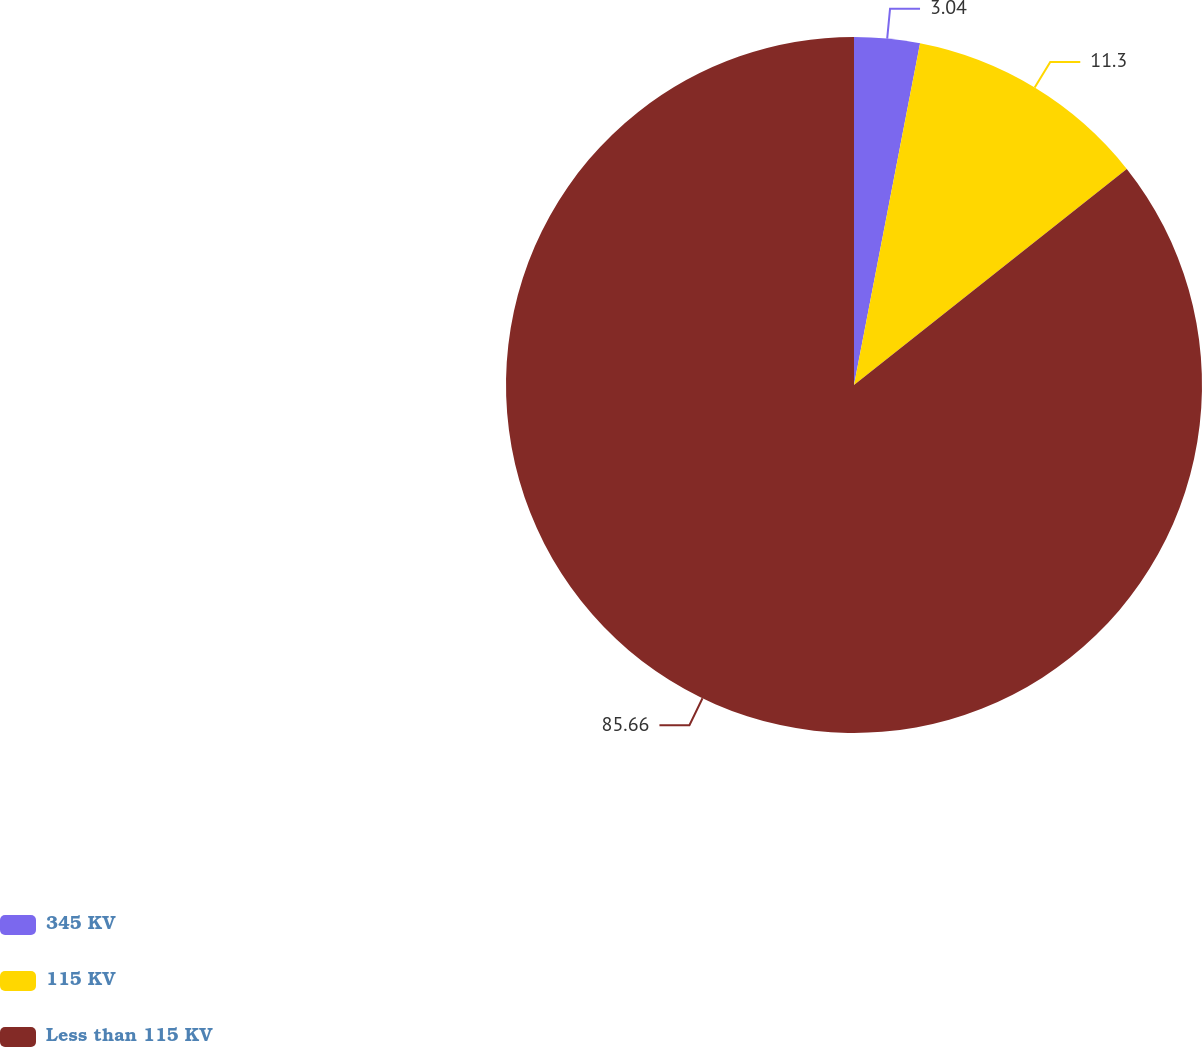<chart> <loc_0><loc_0><loc_500><loc_500><pie_chart><fcel>345 KV<fcel>115 KV<fcel>Less than 115 KV<nl><fcel>3.04%<fcel>11.3%<fcel>85.67%<nl></chart> 